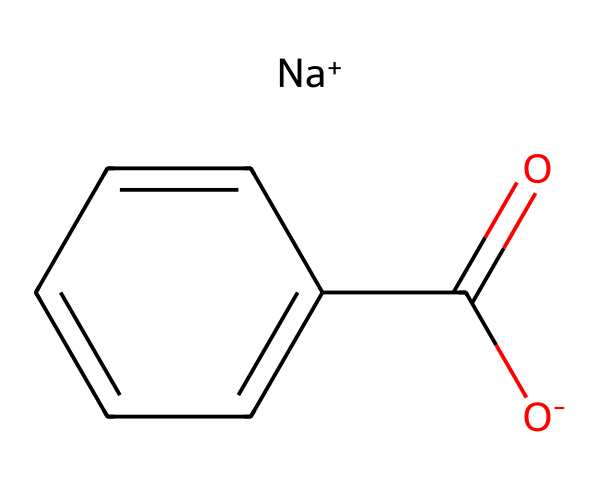How many carbon atoms are present in the structure? The SMILES representation shows "c1ccccc1" which indicates a benzene ring containing 6 carbon atoms, plus one carbon from "C(=O)", totaling 7 carbon atoms.
Answer: seven What is the functional group present in sodium benzoate? The part of the SMILES "C(=O)" indicates a carboxylate group (-COO-), which is characteristic of acids and is crucial for its preservative function.
Answer: carboxylate What is the oxidation state of the sodium ion in this compound? In the SMILES representation, the "[Na+]" indicates that sodium has a +1 oxidation state, which is typical for sodium cations.
Answer: +1 How many total atoms are in sodium benzoate? The SMILES includes 7 carbon, 5 hydrogen, 1 sodium, and 2 oxygen atoms, totaling up to 15 atoms in the compound.
Answer: fifteen What type of compound is sodium benzoate classified as? Sodium benzoate is identified due to its sodium salt form of benzoic acid, functioning primarily as a food preservative, thus classifying it as a food additive.
Answer: food additive What type of bond is present between the carbon and the carbonyl oxygen? The representation "C(=O)" specifies a double bond between the carbon (C) of the carbon chain and an oxygen, indicating the presence of a carbonyl functional group.
Answer: double bond How does the presence of the sodium ion affect its solubility? The involvement of "[Na+]" implies that sodium benzoate is soluble in water, as ionic compounds generally increase solubility through interactions with water molecules.
Answer: increases solubility 